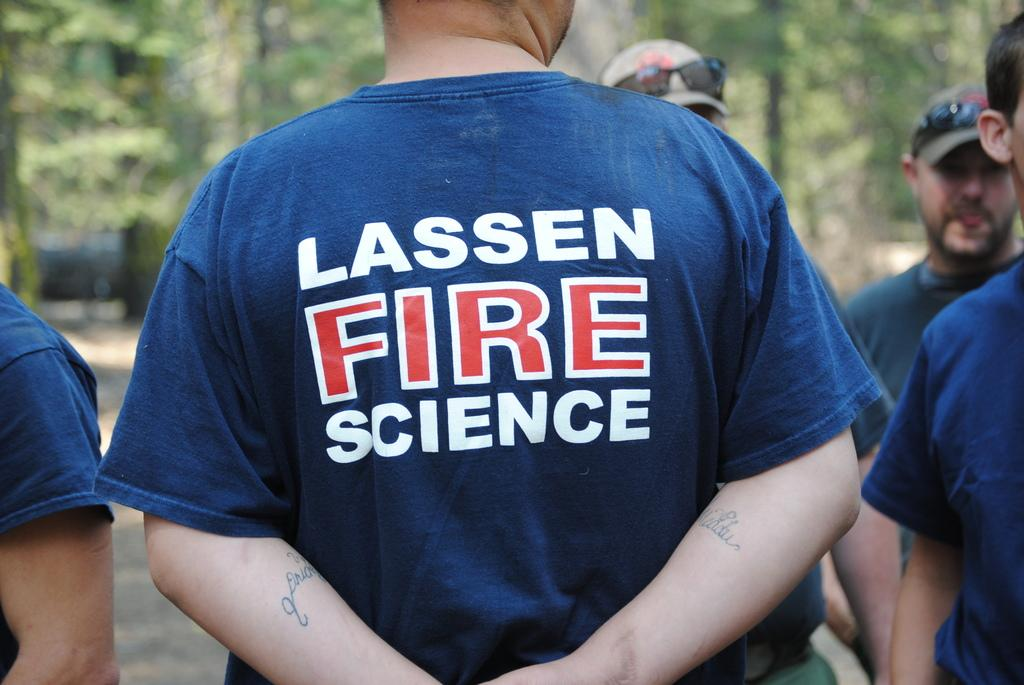<image>
Share a concise interpretation of the image provided. A man in a Lassen Fire Science shirt stands with his hands behind his back. 